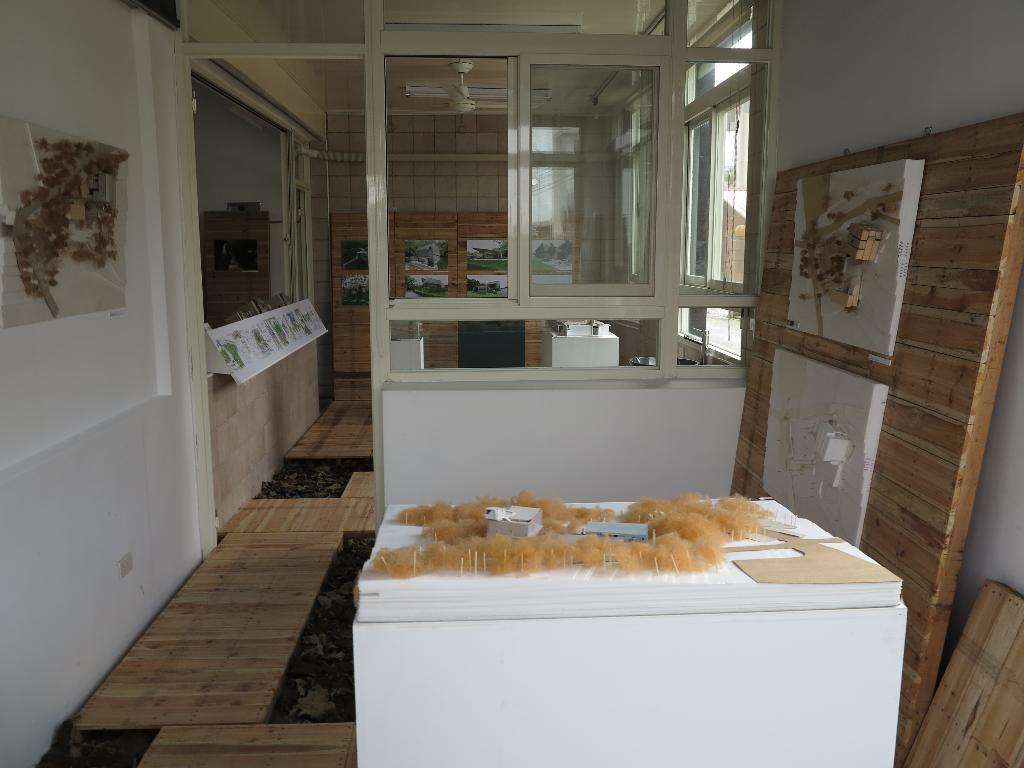How would you summarize this image in a sentence or two? In this image I can see a counter, wall, windows, fan and wall paintings. This image is taken in a room. 